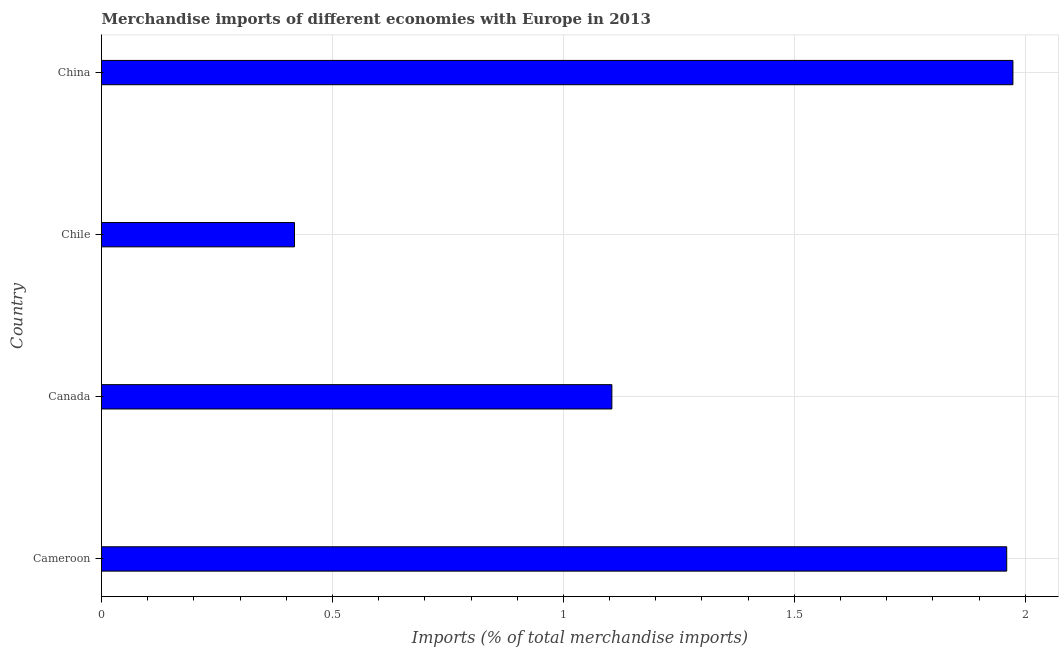Does the graph contain any zero values?
Provide a succinct answer. No. What is the title of the graph?
Offer a very short reply. Merchandise imports of different economies with Europe in 2013. What is the label or title of the X-axis?
Ensure brevity in your answer.  Imports (% of total merchandise imports). What is the merchandise imports in Cameroon?
Offer a terse response. 1.96. Across all countries, what is the maximum merchandise imports?
Offer a very short reply. 1.97. Across all countries, what is the minimum merchandise imports?
Offer a very short reply. 0.42. In which country was the merchandise imports minimum?
Your answer should be compact. Chile. What is the sum of the merchandise imports?
Provide a succinct answer. 5.46. What is the difference between the merchandise imports in Chile and China?
Give a very brief answer. -1.56. What is the average merchandise imports per country?
Provide a short and direct response. 1.36. What is the median merchandise imports?
Your answer should be very brief. 1.53. In how many countries, is the merchandise imports greater than 0.5 %?
Your response must be concise. 3. What is the difference between the highest and the second highest merchandise imports?
Ensure brevity in your answer.  0.01. Is the sum of the merchandise imports in Canada and Chile greater than the maximum merchandise imports across all countries?
Offer a terse response. No. What is the difference between the highest and the lowest merchandise imports?
Keep it short and to the point. 1.56. How many bars are there?
Offer a terse response. 4. Are all the bars in the graph horizontal?
Offer a terse response. Yes. What is the difference between two consecutive major ticks on the X-axis?
Ensure brevity in your answer.  0.5. What is the Imports (% of total merchandise imports) in Cameroon?
Your answer should be compact. 1.96. What is the Imports (% of total merchandise imports) in Canada?
Offer a terse response. 1.11. What is the Imports (% of total merchandise imports) in Chile?
Keep it short and to the point. 0.42. What is the Imports (% of total merchandise imports) of China?
Your answer should be compact. 1.97. What is the difference between the Imports (% of total merchandise imports) in Cameroon and Canada?
Give a very brief answer. 0.85. What is the difference between the Imports (% of total merchandise imports) in Cameroon and Chile?
Provide a succinct answer. 1.54. What is the difference between the Imports (% of total merchandise imports) in Cameroon and China?
Offer a terse response. -0.01. What is the difference between the Imports (% of total merchandise imports) in Canada and Chile?
Give a very brief answer. 0.69. What is the difference between the Imports (% of total merchandise imports) in Canada and China?
Offer a terse response. -0.87. What is the difference between the Imports (% of total merchandise imports) in Chile and China?
Give a very brief answer. -1.56. What is the ratio of the Imports (% of total merchandise imports) in Cameroon to that in Canada?
Your response must be concise. 1.77. What is the ratio of the Imports (% of total merchandise imports) in Cameroon to that in Chile?
Offer a very short reply. 4.69. What is the ratio of the Imports (% of total merchandise imports) in Canada to that in Chile?
Provide a succinct answer. 2.65. What is the ratio of the Imports (% of total merchandise imports) in Canada to that in China?
Provide a short and direct response. 0.56. What is the ratio of the Imports (% of total merchandise imports) in Chile to that in China?
Ensure brevity in your answer.  0.21. 